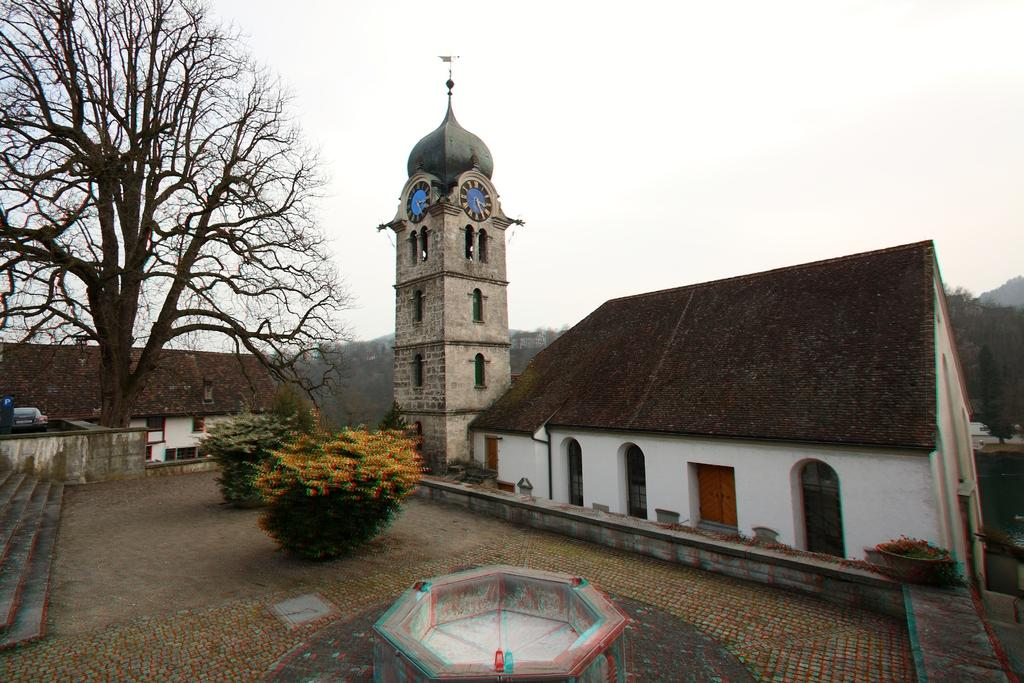What type of structures can be seen in the image? There are houses in the image. What is located on the tower in the image? There are clocks on the tower in the image. What type of vegetation is in front of the houses? There are shrubs and trees in front of the houses. What is parked in front of the houses? There is a vehicle in front of the houses. What account number is associated with the vehicle in the image? There is no account number associated with the vehicle in the image, as it is a parked vehicle and not a financial transaction. 